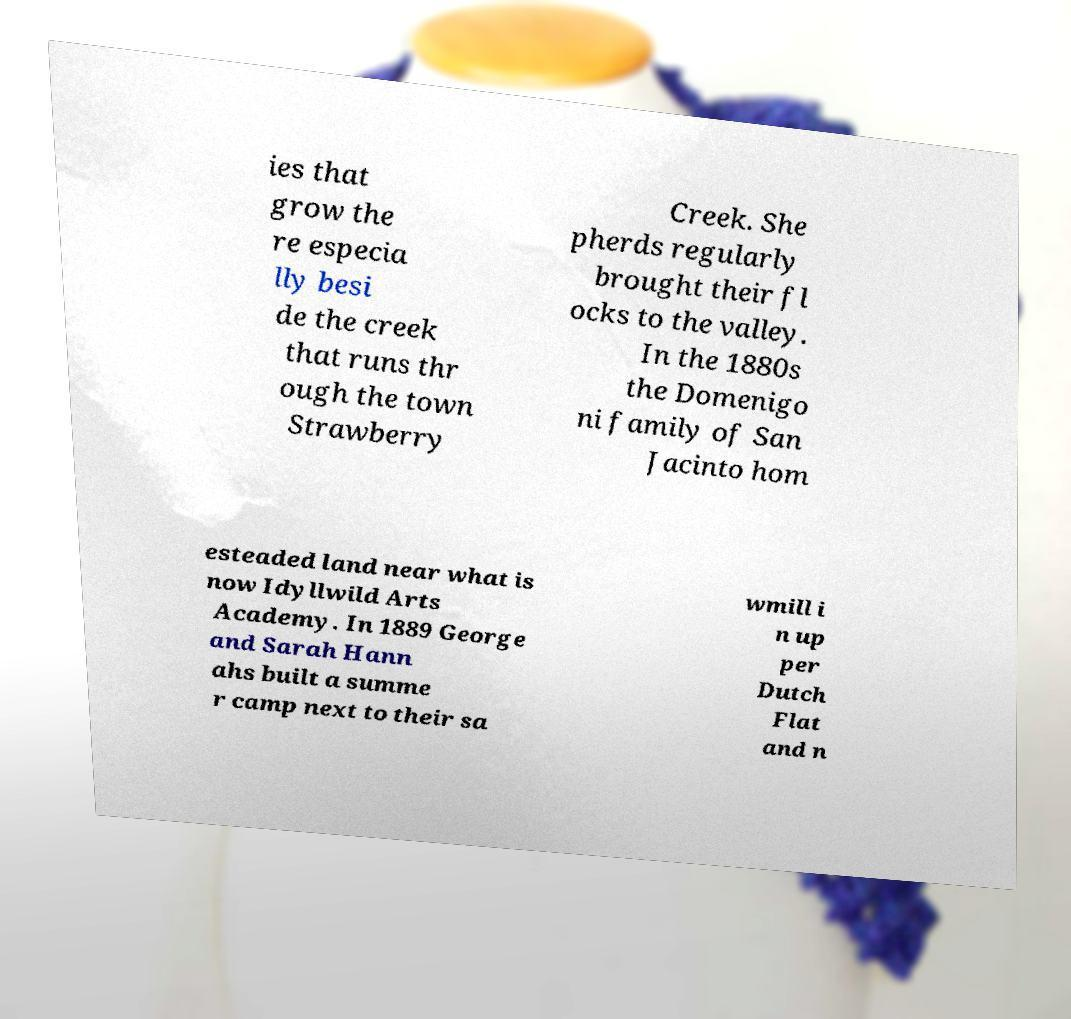There's text embedded in this image that I need extracted. Can you transcribe it verbatim? ies that grow the re especia lly besi de the creek that runs thr ough the town Strawberry Creek. She pherds regularly brought their fl ocks to the valley. In the 1880s the Domenigo ni family of San Jacinto hom esteaded land near what is now Idyllwild Arts Academy. In 1889 George and Sarah Hann ahs built a summe r camp next to their sa wmill i n up per Dutch Flat and n 